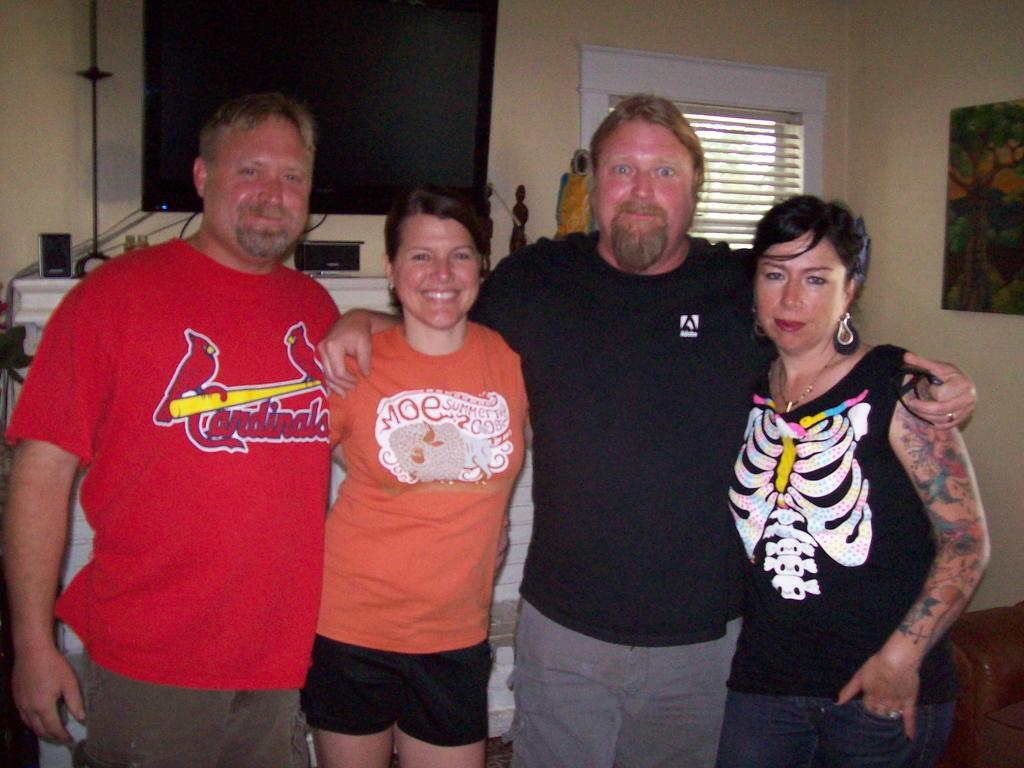<image>
Describe the image concisely. A group of friends wearing t-shirts, one cardinals shirt, Moe's summer top, a black top and a skeleton one. 